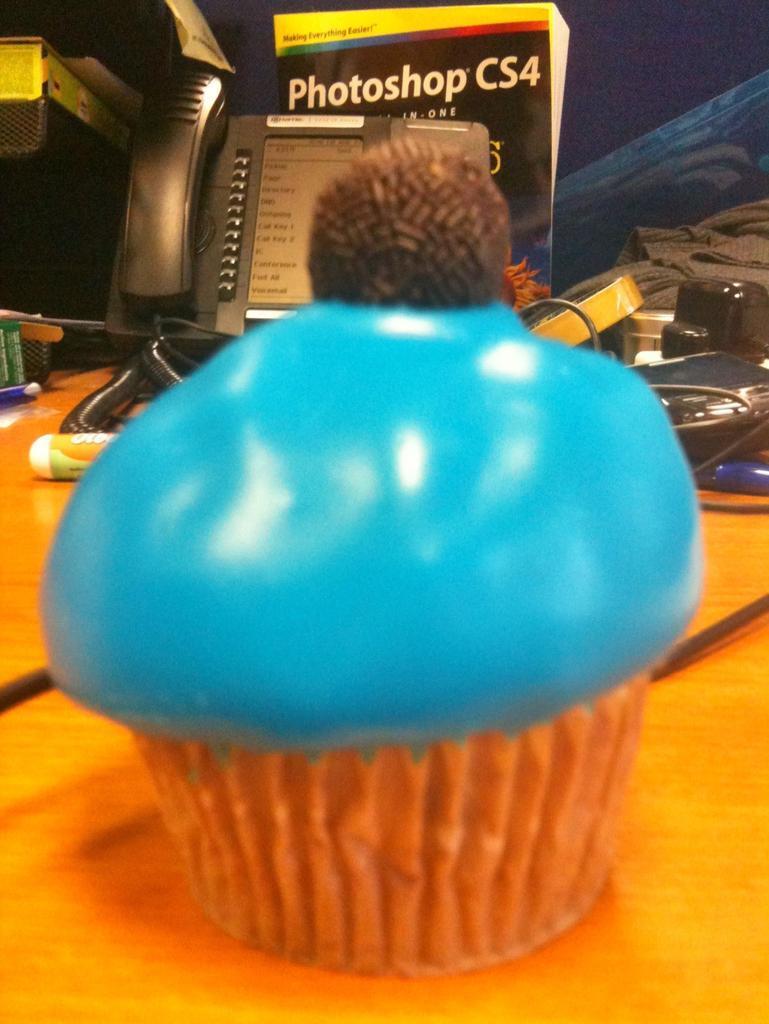Describe this image in one or two sentences. In the middle of this image, there is a chocolate arranged on a surface of a blue color cream, which is in a cup. This cup is placed on a table. In the background, there are a poster, a cable and other objects. 